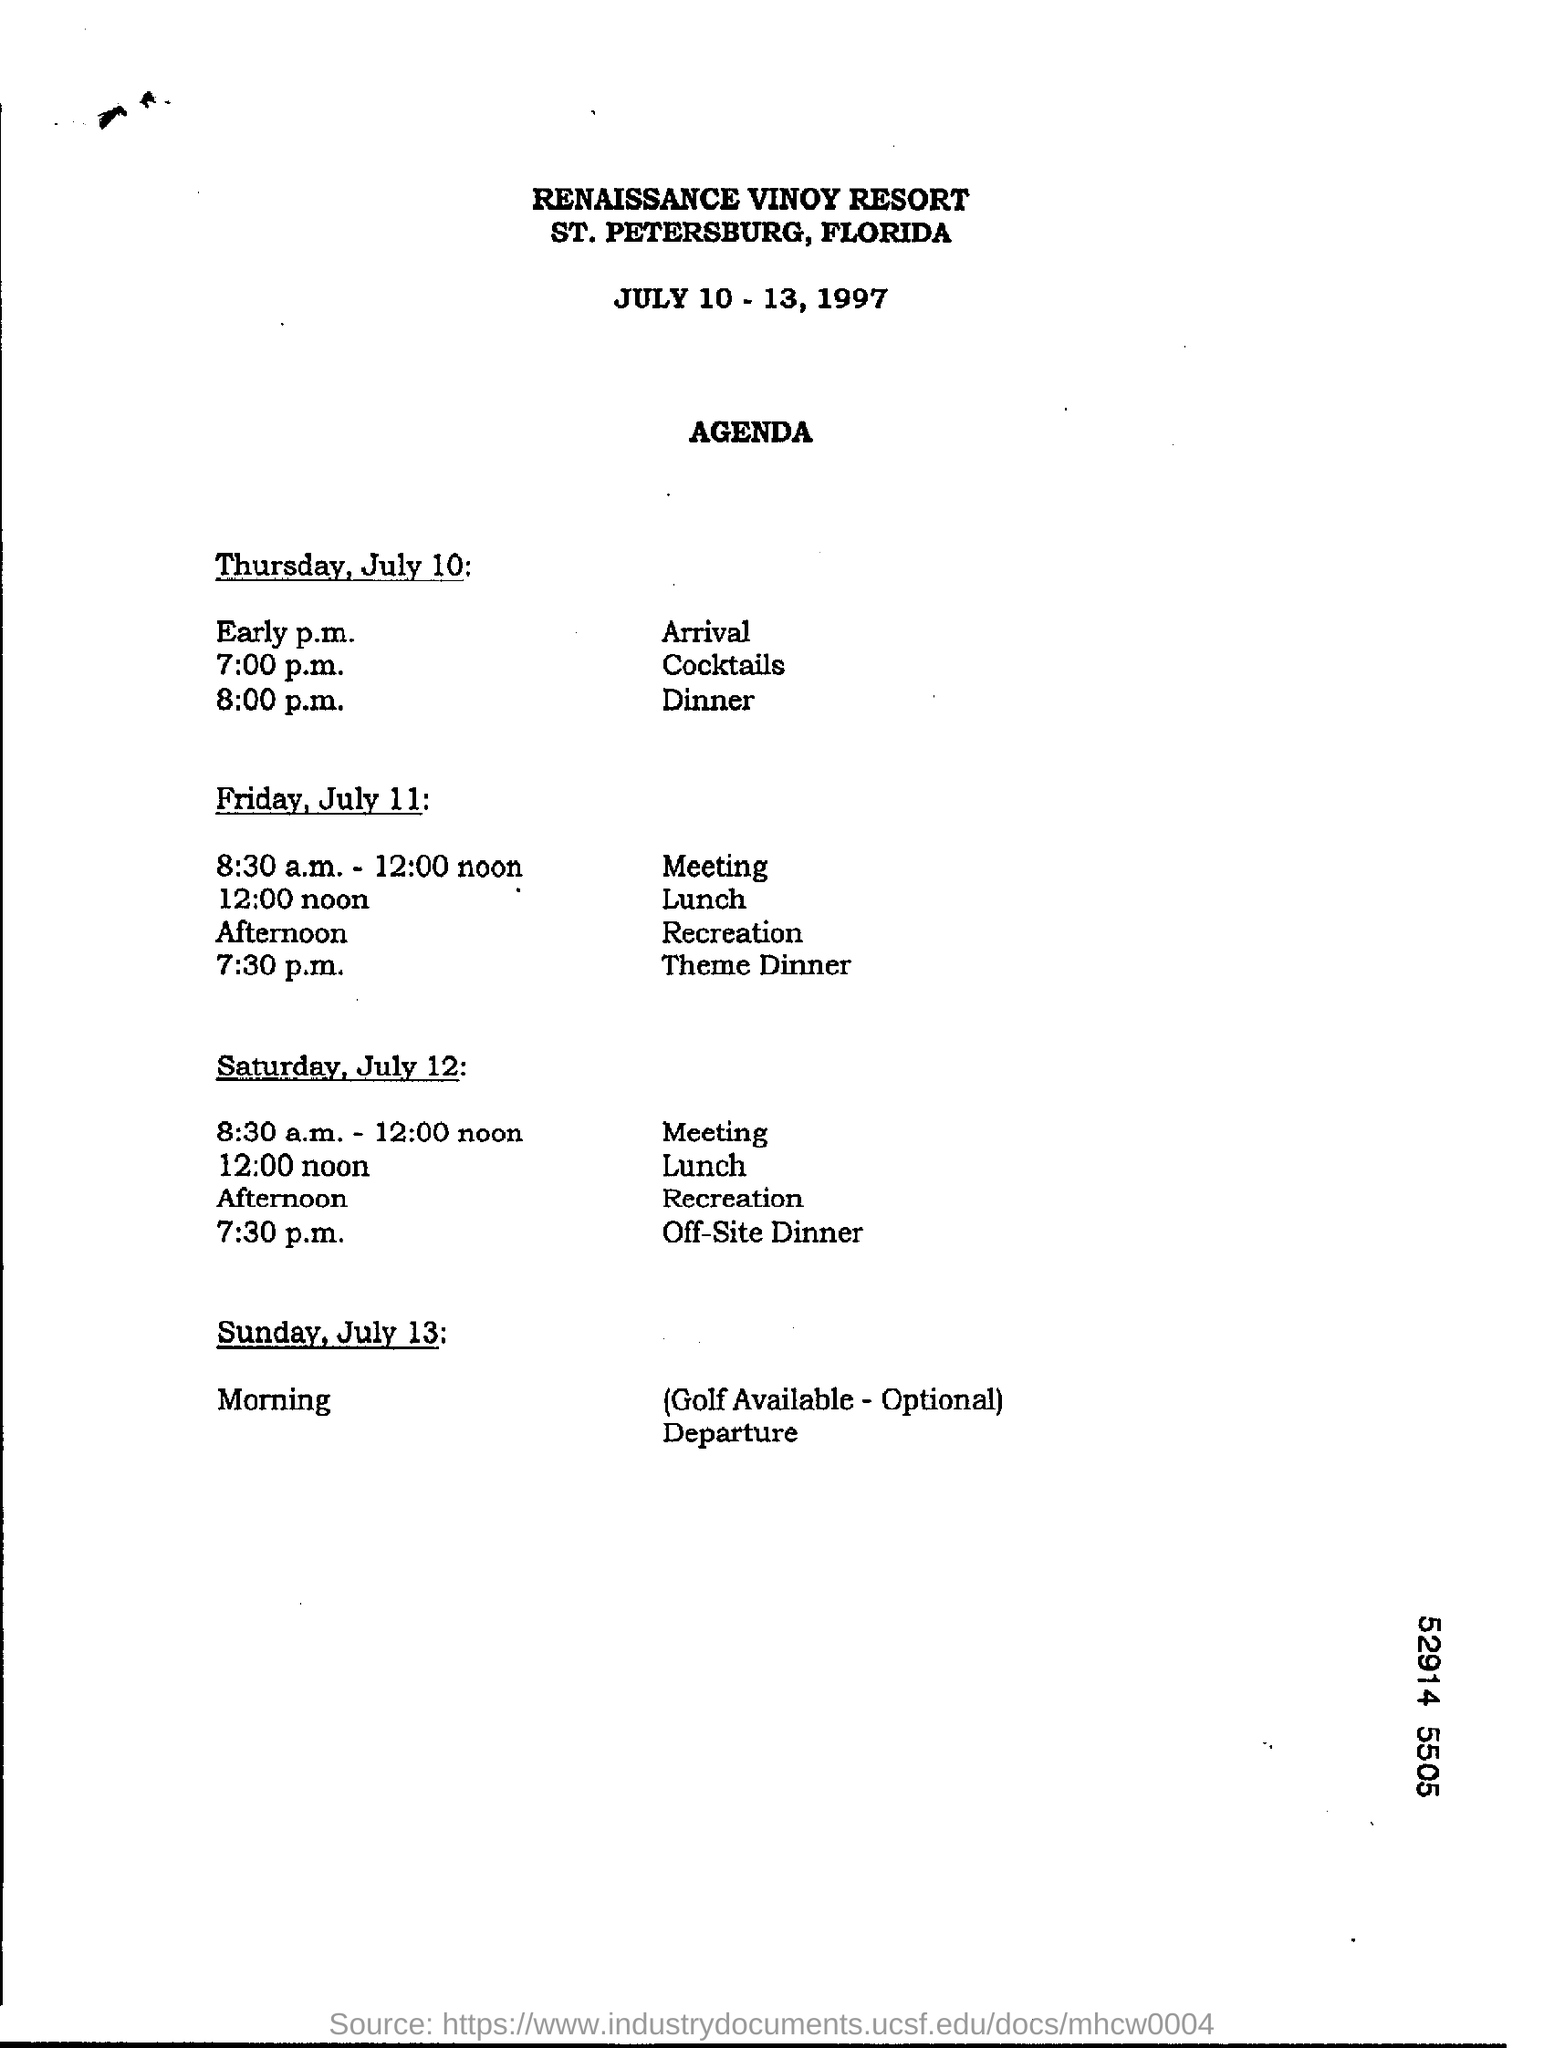Highlight a few significant elements in this photo. The theme dinner is scheduled to take place on Friday, July 11, at 7:30 p.m. The agenda for the Renaissance Vinyard Resort is given here. The meeting has been scheduled for Saturday, July 12, at 8:30 a.m. to 12:00 noon. On Friday, July 11, the lunchtime is 12:00 noon. A dinner scheduled off-site on Saturday, July 12, at 7:30 p.m. 